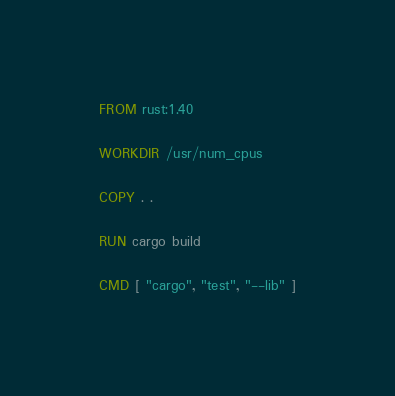Convert code to text. <code><loc_0><loc_0><loc_500><loc_500><_Dockerfile_>FROM rust:1.40

WORKDIR /usr/num_cpus

COPY . .

RUN cargo build

CMD [ "cargo", "test", "--lib" ]
</code> 